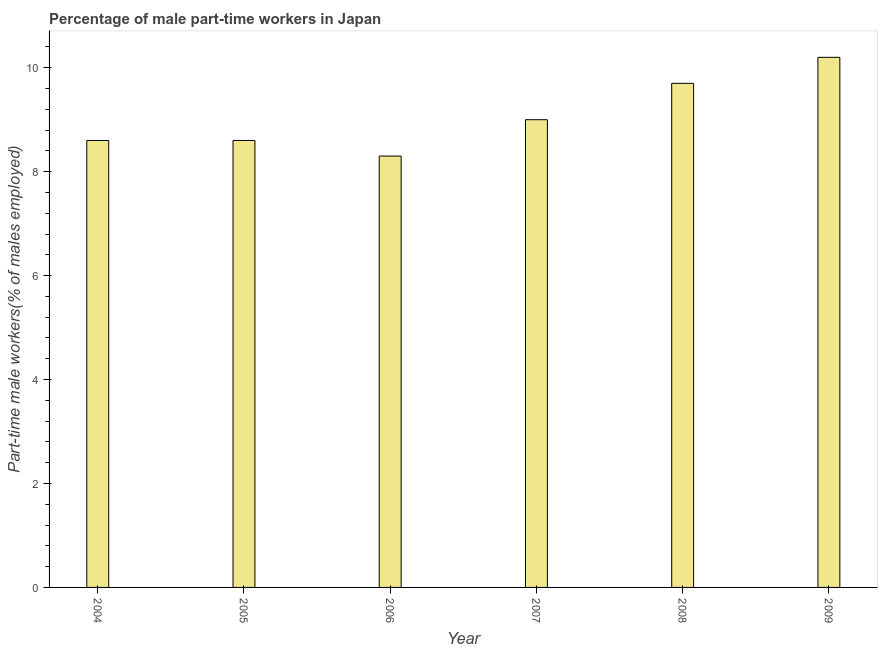Does the graph contain grids?
Offer a terse response. No. What is the title of the graph?
Keep it short and to the point. Percentage of male part-time workers in Japan. What is the label or title of the Y-axis?
Provide a short and direct response. Part-time male workers(% of males employed). What is the percentage of part-time male workers in 2006?
Keep it short and to the point. 8.3. Across all years, what is the maximum percentage of part-time male workers?
Keep it short and to the point. 10.2. Across all years, what is the minimum percentage of part-time male workers?
Keep it short and to the point. 8.3. In which year was the percentage of part-time male workers maximum?
Your answer should be compact. 2009. In which year was the percentage of part-time male workers minimum?
Your response must be concise. 2006. What is the sum of the percentage of part-time male workers?
Offer a terse response. 54.4. What is the difference between the percentage of part-time male workers in 2004 and 2009?
Ensure brevity in your answer.  -1.6. What is the average percentage of part-time male workers per year?
Keep it short and to the point. 9.07. What is the median percentage of part-time male workers?
Keep it short and to the point. 8.8. In how many years, is the percentage of part-time male workers greater than 6.8 %?
Provide a short and direct response. 6. What is the ratio of the percentage of part-time male workers in 2007 to that in 2008?
Ensure brevity in your answer.  0.93. Is the percentage of part-time male workers in 2004 less than that in 2008?
Offer a very short reply. Yes. Is the difference between the percentage of part-time male workers in 2004 and 2007 greater than the difference between any two years?
Offer a very short reply. No. What is the difference between the highest and the second highest percentage of part-time male workers?
Give a very brief answer. 0.5. Are all the bars in the graph horizontal?
Make the answer very short. No. How many years are there in the graph?
Give a very brief answer. 6. Are the values on the major ticks of Y-axis written in scientific E-notation?
Offer a very short reply. No. What is the Part-time male workers(% of males employed) of 2004?
Make the answer very short. 8.6. What is the Part-time male workers(% of males employed) of 2005?
Offer a very short reply. 8.6. What is the Part-time male workers(% of males employed) in 2006?
Give a very brief answer. 8.3. What is the Part-time male workers(% of males employed) of 2008?
Offer a terse response. 9.7. What is the Part-time male workers(% of males employed) of 2009?
Your answer should be compact. 10.2. What is the difference between the Part-time male workers(% of males employed) in 2004 and 2005?
Give a very brief answer. 0. What is the difference between the Part-time male workers(% of males employed) in 2004 and 2008?
Your answer should be very brief. -1.1. What is the difference between the Part-time male workers(% of males employed) in 2005 and 2006?
Your response must be concise. 0.3. What is the difference between the Part-time male workers(% of males employed) in 2005 and 2007?
Offer a terse response. -0.4. What is the difference between the Part-time male workers(% of males employed) in 2006 and 2007?
Ensure brevity in your answer.  -0.7. What is the difference between the Part-time male workers(% of males employed) in 2007 and 2008?
Offer a very short reply. -0.7. What is the difference between the Part-time male workers(% of males employed) in 2007 and 2009?
Your answer should be compact. -1.2. What is the difference between the Part-time male workers(% of males employed) in 2008 and 2009?
Provide a succinct answer. -0.5. What is the ratio of the Part-time male workers(% of males employed) in 2004 to that in 2005?
Your answer should be very brief. 1. What is the ratio of the Part-time male workers(% of males employed) in 2004 to that in 2006?
Keep it short and to the point. 1.04. What is the ratio of the Part-time male workers(% of males employed) in 2004 to that in 2007?
Offer a very short reply. 0.96. What is the ratio of the Part-time male workers(% of males employed) in 2004 to that in 2008?
Your answer should be very brief. 0.89. What is the ratio of the Part-time male workers(% of males employed) in 2004 to that in 2009?
Provide a succinct answer. 0.84. What is the ratio of the Part-time male workers(% of males employed) in 2005 to that in 2006?
Keep it short and to the point. 1.04. What is the ratio of the Part-time male workers(% of males employed) in 2005 to that in 2007?
Offer a terse response. 0.96. What is the ratio of the Part-time male workers(% of males employed) in 2005 to that in 2008?
Ensure brevity in your answer.  0.89. What is the ratio of the Part-time male workers(% of males employed) in 2005 to that in 2009?
Provide a succinct answer. 0.84. What is the ratio of the Part-time male workers(% of males employed) in 2006 to that in 2007?
Your answer should be compact. 0.92. What is the ratio of the Part-time male workers(% of males employed) in 2006 to that in 2008?
Make the answer very short. 0.86. What is the ratio of the Part-time male workers(% of males employed) in 2006 to that in 2009?
Provide a short and direct response. 0.81. What is the ratio of the Part-time male workers(% of males employed) in 2007 to that in 2008?
Make the answer very short. 0.93. What is the ratio of the Part-time male workers(% of males employed) in 2007 to that in 2009?
Your answer should be very brief. 0.88. What is the ratio of the Part-time male workers(% of males employed) in 2008 to that in 2009?
Your answer should be compact. 0.95. 